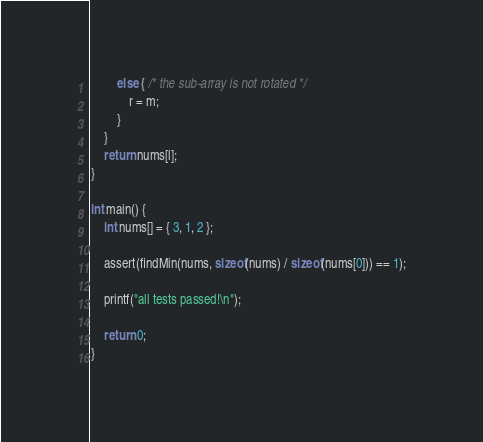Convert code to text. <code><loc_0><loc_0><loc_500><loc_500><_C_>        else { /* the sub-array is not rotated */
            r = m;
        }
    }
    return nums[l];
}

int main() {
    int nums[] = { 3, 1, 2 };

    assert(findMin(nums, sizeof(nums) / sizeof(nums[0])) == 1);

    printf("all tests passed!\n");

    return 0;
}
</code> 